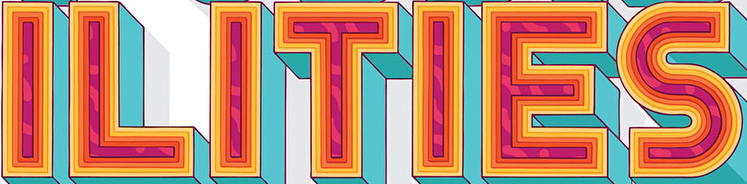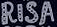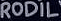Read the text from these images in sequence, separated by a semicolon. ILITIES; RISA; RODIL 